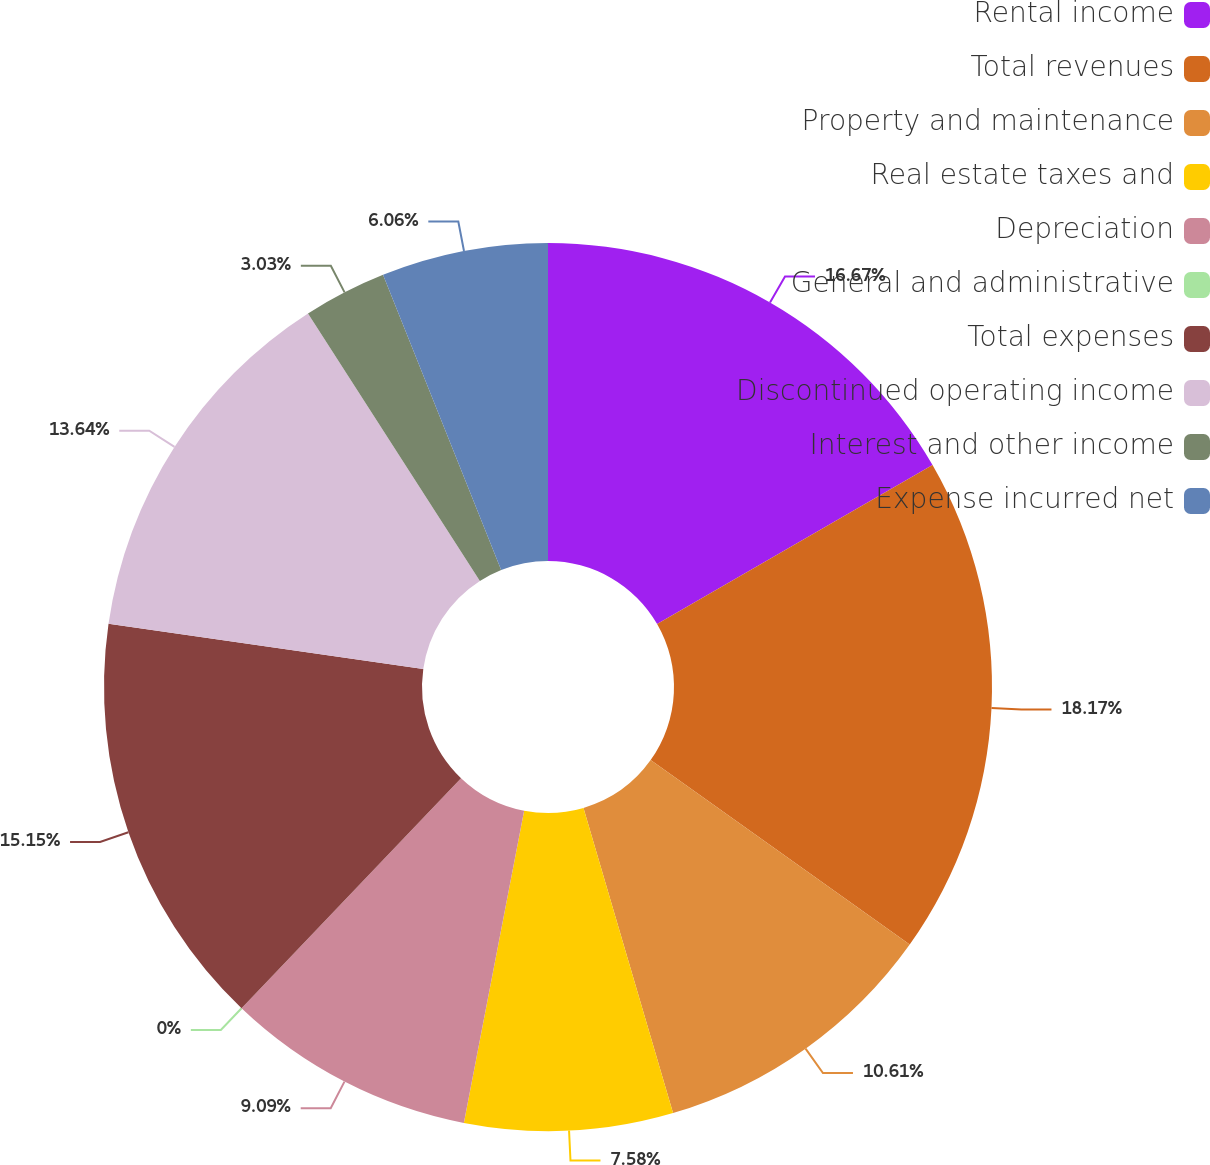Convert chart to OTSL. <chart><loc_0><loc_0><loc_500><loc_500><pie_chart><fcel>Rental income<fcel>Total revenues<fcel>Property and maintenance<fcel>Real estate taxes and<fcel>Depreciation<fcel>General and administrative<fcel>Total expenses<fcel>Discontinued operating income<fcel>Interest and other income<fcel>Expense incurred net<nl><fcel>16.67%<fcel>18.18%<fcel>10.61%<fcel>7.58%<fcel>9.09%<fcel>0.0%<fcel>15.15%<fcel>13.64%<fcel>3.03%<fcel>6.06%<nl></chart> 